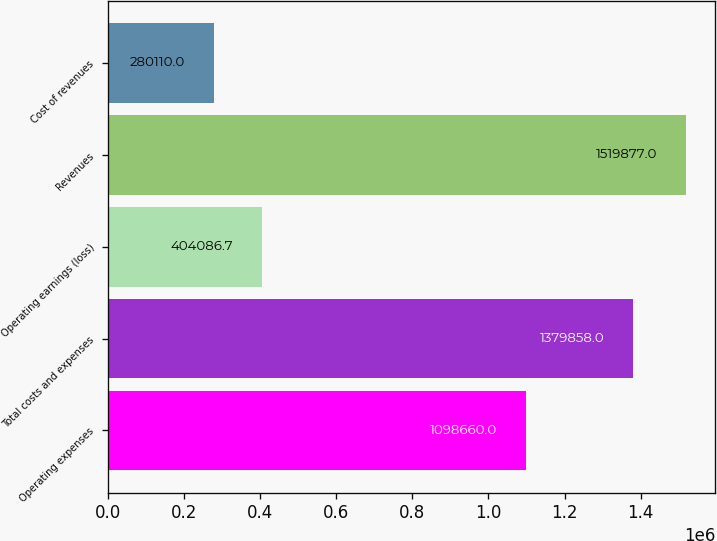Convert chart to OTSL. <chart><loc_0><loc_0><loc_500><loc_500><bar_chart><fcel>Operating expenses<fcel>Total costs and expenses<fcel>Operating earnings (loss)<fcel>Revenues<fcel>Cost of revenues<nl><fcel>1.09866e+06<fcel>1.37986e+06<fcel>404087<fcel>1.51988e+06<fcel>280110<nl></chart> 